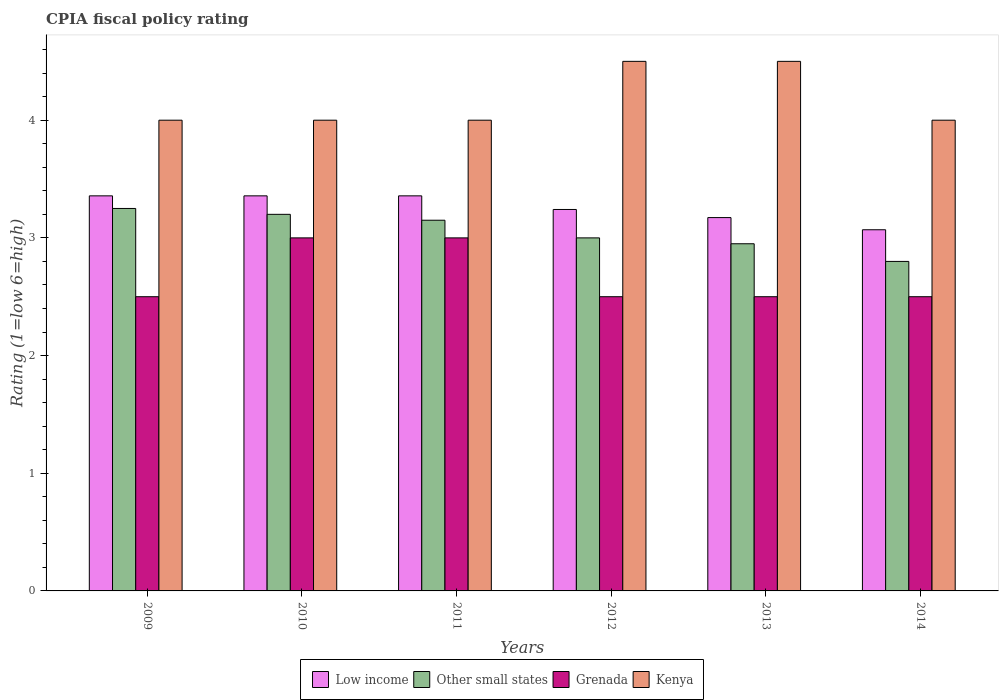How many different coloured bars are there?
Keep it short and to the point. 4. Are the number of bars per tick equal to the number of legend labels?
Give a very brief answer. Yes. How many bars are there on the 3rd tick from the left?
Give a very brief answer. 4. What is the label of the 5th group of bars from the left?
Keep it short and to the point. 2013. What is the CPIA rating in Kenya in 2013?
Provide a succinct answer. 4.5. Across all years, what is the maximum CPIA rating in Grenada?
Your answer should be very brief. 3. In which year was the CPIA rating in Low income minimum?
Your response must be concise. 2014. What is the total CPIA rating in Low income in the graph?
Give a very brief answer. 19.55. What is the difference between the CPIA rating in Other small states in 2010 and that in 2012?
Keep it short and to the point. 0.2. What is the difference between the CPIA rating in Grenada in 2010 and the CPIA rating in Kenya in 2009?
Make the answer very short. -1. What is the average CPIA rating in Kenya per year?
Your answer should be very brief. 4.17. In the year 2012, what is the difference between the CPIA rating in Kenya and CPIA rating in Low income?
Offer a terse response. 1.26. In how many years, is the CPIA rating in Grenada greater than 2.4?
Provide a short and direct response. 6. What is the ratio of the CPIA rating in Other small states in 2010 to that in 2013?
Offer a terse response. 1.08. Is the CPIA rating in Low income in 2012 less than that in 2014?
Make the answer very short. No. What is the difference between the highest and the lowest CPIA rating in Low income?
Ensure brevity in your answer.  0.29. What does the 2nd bar from the left in 2013 represents?
Ensure brevity in your answer.  Other small states. What does the 3rd bar from the right in 2012 represents?
Your answer should be compact. Other small states. How many bars are there?
Provide a short and direct response. 24. Are all the bars in the graph horizontal?
Offer a very short reply. No. Are the values on the major ticks of Y-axis written in scientific E-notation?
Provide a succinct answer. No. How many legend labels are there?
Give a very brief answer. 4. What is the title of the graph?
Your answer should be compact. CPIA fiscal policy rating. Does "Guatemala" appear as one of the legend labels in the graph?
Your answer should be very brief. No. What is the Rating (1=low 6=high) of Low income in 2009?
Offer a terse response. 3.36. What is the Rating (1=low 6=high) in Other small states in 2009?
Your answer should be compact. 3.25. What is the Rating (1=low 6=high) of Kenya in 2009?
Your answer should be very brief. 4. What is the Rating (1=low 6=high) in Low income in 2010?
Ensure brevity in your answer.  3.36. What is the Rating (1=low 6=high) in Grenada in 2010?
Your response must be concise. 3. What is the Rating (1=low 6=high) in Kenya in 2010?
Give a very brief answer. 4. What is the Rating (1=low 6=high) in Low income in 2011?
Your response must be concise. 3.36. What is the Rating (1=low 6=high) in Other small states in 2011?
Your response must be concise. 3.15. What is the Rating (1=low 6=high) of Grenada in 2011?
Ensure brevity in your answer.  3. What is the Rating (1=low 6=high) of Low income in 2012?
Your answer should be very brief. 3.24. What is the Rating (1=low 6=high) in Grenada in 2012?
Offer a very short reply. 2.5. What is the Rating (1=low 6=high) of Low income in 2013?
Make the answer very short. 3.17. What is the Rating (1=low 6=high) of Other small states in 2013?
Offer a terse response. 2.95. What is the Rating (1=low 6=high) in Kenya in 2013?
Provide a succinct answer. 4.5. What is the Rating (1=low 6=high) in Low income in 2014?
Provide a succinct answer. 3.07. What is the Rating (1=low 6=high) of Kenya in 2014?
Your answer should be compact. 4. Across all years, what is the maximum Rating (1=low 6=high) of Low income?
Your answer should be compact. 3.36. Across all years, what is the maximum Rating (1=low 6=high) in Other small states?
Ensure brevity in your answer.  3.25. Across all years, what is the maximum Rating (1=low 6=high) of Grenada?
Provide a succinct answer. 3. Across all years, what is the minimum Rating (1=low 6=high) in Low income?
Provide a succinct answer. 3.07. Across all years, what is the minimum Rating (1=low 6=high) of Grenada?
Offer a terse response. 2.5. What is the total Rating (1=low 6=high) in Low income in the graph?
Keep it short and to the point. 19.55. What is the total Rating (1=low 6=high) of Other small states in the graph?
Make the answer very short. 18.35. What is the total Rating (1=low 6=high) in Grenada in the graph?
Your answer should be very brief. 16. What is the difference between the Rating (1=low 6=high) of Grenada in 2009 and that in 2010?
Keep it short and to the point. -0.5. What is the difference between the Rating (1=low 6=high) in Grenada in 2009 and that in 2011?
Offer a terse response. -0.5. What is the difference between the Rating (1=low 6=high) in Kenya in 2009 and that in 2011?
Your answer should be compact. 0. What is the difference between the Rating (1=low 6=high) in Low income in 2009 and that in 2012?
Provide a short and direct response. 0.12. What is the difference between the Rating (1=low 6=high) in Grenada in 2009 and that in 2012?
Give a very brief answer. 0. What is the difference between the Rating (1=low 6=high) in Kenya in 2009 and that in 2012?
Offer a terse response. -0.5. What is the difference between the Rating (1=low 6=high) in Low income in 2009 and that in 2013?
Keep it short and to the point. 0.18. What is the difference between the Rating (1=low 6=high) of Low income in 2009 and that in 2014?
Ensure brevity in your answer.  0.29. What is the difference between the Rating (1=low 6=high) in Other small states in 2009 and that in 2014?
Offer a very short reply. 0.45. What is the difference between the Rating (1=low 6=high) in Kenya in 2009 and that in 2014?
Your answer should be compact. 0. What is the difference between the Rating (1=low 6=high) in Low income in 2010 and that in 2011?
Make the answer very short. 0. What is the difference between the Rating (1=low 6=high) of Grenada in 2010 and that in 2011?
Keep it short and to the point. 0. What is the difference between the Rating (1=low 6=high) of Low income in 2010 and that in 2012?
Your answer should be very brief. 0.12. What is the difference between the Rating (1=low 6=high) in Other small states in 2010 and that in 2012?
Your answer should be compact. 0.2. What is the difference between the Rating (1=low 6=high) of Grenada in 2010 and that in 2012?
Make the answer very short. 0.5. What is the difference between the Rating (1=low 6=high) of Kenya in 2010 and that in 2012?
Offer a very short reply. -0.5. What is the difference between the Rating (1=low 6=high) of Low income in 2010 and that in 2013?
Your answer should be very brief. 0.18. What is the difference between the Rating (1=low 6=high) in Grenada in 2010 and that in 2013?
Ensure brevity in your answer.  0.5. What is the difference between the Rating (1=low 6=high) in Low income in 2010 and that in 2014?
Offer a terse response. 0.29. What is the difference between the Rating (1=low 6=high) of Other small states in 2010 and that in 2014?
Make the answer very short. 0.4. What is the difference between the Rating (1=low 6=high) of Low income in 2011 and that in 2012?
Your answer should be very brief. 0.12. What is the difference between the Rating (1=low 6=high) of Kenya in 2011 and that in 2012?
Provide a succinct answer. -0.5. What is the difference between the Rating (1=low 6=high) of Low income in 2011 and that in 2013?
Your answer should be very brief. 0.18. What is the difference between the Rating (1=low 6=high) of Kenya in 2011 and that in 2013?
Keep it short and to the point. -0.5. What is the difference between the Rating (1=low 6=high) of Low income in 2011 and that in 2014?
Offer a terse response. 0.29. What is the difference between the Rating (1=low 6=high) of Other small states in 2011 and that in 2014?
Offer a terse response. 0.35. What is the difference between the Rating (1=low 6=high) of Grenada in 2011 and that in 2014?
Make the answer very short. 0.5. What is the difference between the Rating (1=low 6=high) of Kenya in 2011 and that in 2014?
Make the answer very short. 0. What is the difference between the Rating (1=low 6=high) of Low income in 2012 and that in 2013?
Keep it short and to the point. 0.07. What is the difference between the Rating (1=low 6=high) of Other small states in 2012 and that in 2013?
Make the answer very short. 0.05. What is the difference between the Rating (1=low 6=high) of Kenya in 2012 and that in 2013?
Give a very brief answer. 0. What is the difference between the Rating (1=low 6=high) of Low income in 2012 and that in 2014?
Offer a very short reply. 0.17. What is the difference between the Rating (1=low 6=high) of Other small states in 2012 and that in 2014?
Make the answer very short. 0.2. What is the difference between the Rating (1=low 6=high) in Grenada in 2012 and that in 2014?
Give a very brief answer. 0. What is the difference between the Rating (1=low 6=high) in Low income in 2013 and that in 2014?
Provide a succinct answer. 0.1. What is the difference between the Rating (1=low 6=high) of Grenada in 2013 and that in 2014?
Offer a very short reply. 0. What is the difference between the Rating (1=low 6=high) of Low income in 2009 and the Rating (1=low 6=high) of Other small states in 2010?
Make the answer very short. 0.16. What is the difference between the Rating (1=low 6=high) in Low income in 2009 and the Rating (1=low 6=high) in Grenada in 2010?
Keep it short and to the point. 0.36. What is the difference between the Rating (1=low 6=high) of Low income in 2009 and the Rating (1=low 6=high) of Kenya in 2010?
Keep it short and to the point. -0.64. What is the difference between the Rating (1=low 6=high) of Other small states in 2009 and the Rating (1=low 6=high) of Grenada in 2010?
Your answer should be very brief. 0.25. What is the difference between the Rating (1=low 6=high) in Other small states in 2009 and the Rating (1=low 6=high) in Kenya in 2010?
Provide a succinct answer. -0.75. What is the difference between the Rating (1=low 6=high) in Low income in 2009 and the Rating (1=low 6=high) in Other small states in 2011?
Give a very brief answer. 0.21. What is the difference between the Rating (1=low 6=high) of Low income in 2009 and the Rating (1=low 6=high) of Grenada in 2011?
Your answer should be compact. 0.36. What is the difference between the Rating (1=low 6=high) in Low income in 2009 and the Rating (1=low 6=high) in Kenya in 2011?
Your answer should be compact. -0.64. What is the difference between the Rating (1=low 6=high) of Other small states in 2009 and the Rating (1=low 6=high) of Grenada in 2011?
Offer a very short reply. 0.25. What is the difference between the Rating (1=low 6=high) in Other small states in 2009 and the Rating (1=low 6=high) in Kenya in 2011?
Your answer should be very brief. -0.75. What is the difference between the Rating (1=low 6=high) of Low income in 2009 and the Rating (1=low 6=high) of Other small states in 2012?
Your response must be concise. 0.36. What is the difference between the Rating (1=low 6=high) of Low income in 2009 and the Rating (1=low 6=high) of Kenya in 2012?
Offer a terse response. -1.14. What is the difference between the Rating (1=low 6=high) of Other small states in 2009 and the Rating (1=low 6=high) of Kenya in 2012?
Provide a short and direct response. -1.25. What is the difference between the Rating (1=low 6=high) of Low income in 2009 and the Rating (1=low 6=high) of Other small states in 2013?
Provide a short and direct response. 0.41. What is the difference between the Rating (1=low 6=high) of Low income in 2009 and the Rating (1=low 6=high) of Grenada in 2013?
Offer a terse response. 0.86. What is the difference between the Rating (1=low 6=high) of Low income in 2009 and the Rating (1=low 6=high) of Kenya in 2013?
Ensure brevity in your answer.  -1.14. What is the difference between the Rating (1=low 6=high) in Other small states in 2009 and the Rating (1=low 6=high) in Grenada in 2013?
Make the answer very short. 0.75. What is the difference between the Rating (1=low 6=high) in Other small states in 2009 and the Rating (1=low 6=high) in Kenya in 2013?
Offer a terse response. -1.25. What is the difference between the Rating (1=low 6=high) of Grenada in 2009 and the Rating (1=low 6=high) of Kenya in 2013?
Give a very brief answer. -2. What is the difference between the Rating (1=low 6=high) of Low income in 2009 and the Rating (1=low 6=high) of Other small states in 2014?
Offer a very short reply. 0.56. What is the difference between the Rating (1=low 6=high) in Low income in 2009 and the Rating (1=low 6=high) in Grenada in 2014?
Make the answer very short. 0.86. What is the difference between the Rating (1=low 6=high) in Low income in 2009 and the Rating (1=low 6=high) in Kenya in 2014?
Provide a short and direct response. -0.64. What is the difference between the Rating (1=low 6=high) of Other small states in 2009 and the Rating (1=low 6=high) of Kenya in 2014?
Give a very brief answer. -0.75. What is the difference between the Rating (1=low 6=high) of Grenada in 2009 and the Rating (1=low 6=high) of Kenya in 2014?
Offer a very short reply. -1.5. What is the difference between the Rating (1=low 6=high) of Low income in 2010 and the Rating (1=low 6=high) of Other small states in 2011?
Provide a succinct answer. 0.21. What is the difference between the Rating (1=low 6=high) of Low income in 2010 and the Rating (1=low 6=high) of Grenada in 2011?
Keep it short and to the point. 0.36. What is the difference between the Rating (1=low 6=high) of Low income in 2010 and the Rating (1=low 6=high) of Kenya in 2011?
Ensure brevity in your answer.  -0.64. What is the difference between the Rating (1=low 6=high) in Low income in 2010 and the Rating (1=low 6=high) in Other small states in 2012?
Keep it short and to the point. 0.36. What is the difference between the Rating (1=low 6=high) in Low income in 2010 and the Rating (1=low 6=high) in Grenada in 2012?
Offer a terse response. 0.86. What is the difference between the Rating (1=low 6=high) of Low income in 2010 and the Rating (1=low 6=high) of Kenya in 2012?
Provide a succinct answer. -1.14. What is the difference between the Rating (1=low 6=high) in Other small states in 2010 and the Rating (1=low 6=high) in Kenya in 2012?
Offer a terse response. -1.3. What is the difference between the Rating (1=low 6=high) in Low income in 2010 and the Rating (1=low 6=high) in Other small states in 2013?
Offer a very short reply. 0.41. What is the difference between the Rating (1=low 6=high) of Low income in 2010 and the Rating (1=low 6=high) of Grenada in 2013?
Provide a short and direct response. 0.86. What is the difference between the Rating (1=low 6=high) in Low income in 2010 and the Rating (1=low 6=high) in Kenya in 2013?
Make the answer very short. -1.14. What is the difference between the Rating (1=low 6=high) in Other small states in 2010 and the Rating (1=low 6=high) in Grenada in 2013?
Keep it short and to the point. 0.7. What is the difference between the Rating (1=low 6=high) of Other small states in 2010 and the Rating (1=low 6=high) of Kenya in 2013?
Provide a short and direct response. -1.3. What is the difference between the Rating (1=low 6=high) of Grenada in 2010 and the Rating (1=low 6=high) of Kenya in 2013?
Your answer should be compact. -1.5. What is the difference between the Rating (1=low 6=high) in Low income in 2010 and the Rating (1=low 6=high) in Other small states in 2014?
Keep it short and to the point. 0.56. What is the difference between the Rating (1=low 6=high) in Low income in 2010 and the Rating (1=low 6=high) in Grenada in 2014?
Provide a succinct answer. 0.86. What is the difference between the Rating (1=low 6=high) of Low income in 2010 and the Rating (1=low 6=high) of Kenya in 2014?
Your answer should be compact. -0.64. What is the difference between the Rating (1=low 6=high) in Other small states in 2010 and the Rating (1=low 6=high) in Kenya in 2014?
Provide a succinct answer. -0.8. What is the difference between the Rating (1=low 6=high) of Low income in 2011 and the Rating (1=low 6=high) of Other small states in 2012?
Offer a very short reply. 0.36. What is the difference between the Rating (1=low 6=high) in Low income in 2011 and the Rating (1=low 6=high) in Grenada in 2012?
Ensure brevity in your answer.  0.86. What is the difference between the Rating (1=low 6=high) in Low income in 2011 and the Rating (1=low 6=high) in Kenya in 2012?
Give a very brief answer. -1.14. What is the difference between the Rating (1=low 6=high) in Other small states in 2011 and the Rating (1=low 6=high) in Grenada in 2012?
Your response must be concise. 0.65. What is the difference between the Rating (1=low 6=high) in Other small states in 2011 and the Rating (1=low 6=high) in Kenya in 2012?
Offer a very short reply. -1.35. What is the difference between the Rating (1=low 6=high) of Grenada in 2011 and the Rating (1=low 6=high) of Kenya in 2012?
Provide a short and direct response. -1.5. What is the difference between the Rating (1=low 6=high) in Low income in 2011 and the Rating (1=low 6=high) in Other small states in 2013?
Your answer should be very brief. 0.41. What is the difference between the Rating (1=low 6=high) in Low income in 2011 and the Rating (1=low 6=high) in Kenya in 2013?
Your answer should be compact. -1.14. What is the difference between the Rating (1=low 6=high) of Other small states in 2011 and the Rating (1=low 6=high) of Grenada in 2013?
Provide a short and direct response. 0.65. What is the difference between the Rating (1=low 6=high) of Other small states in 2011 and the Rating (1=low 6=high) of Kenya in 2013?
Keep it short and to the point. -1.35. What is the difference between the Rating (1=low 6=high) in Low income in 2011 and the Rating (1=low 6=high) in Other small states in 2014?
Provide a short and direct response. 0.56. What is the difference between the Rating (1=low 6=high) in Low income in 2011 and the Rating (1=low 6=high) in Kenya in 2014?
Give a very brief answer. -0.64. What is the difference between the Rating (1=low 6=high) of Other small states in 2011 and the Rating (1=low 6=high) of Grenada in 2014?
Your response must be concise. 0.65. What is the difference between the Rating (1=low 6=high) in Other small states in 2011 and the Rating (1=low 6=high) in Kenya in 2014?
Make the answer very short. -0.85. What is the difference between the Rating (1=low 6=high) in Grenada in 2011 and the Rating (1=low 6=high) in Kenya in 2014?
Ensure brevity in your answer.  -1. What is the difference between the Rating (1=low 6=high) of Low income in 2012 and the Rating (1=low 6=high) of Other small states in 2013?
Make the answer very short. 0.29. What is the difference between the Rating (1=low 6=high) in Low income in 2012 and the Rating (1=low 6=high) in Grenada in 2013?
Offer a very short reply. 0.74. What is the difference between the Rating (1=low 6=high) of Low income in 2012 and the Rating (1=low 6=high) of Kenya in 2013?
Ensure brevity in your answer.  -1.26. What is the difference between the Rating (1=low 6=high) of Other small states in 2012 and the Rating (1=low 6=high) of Grenada in 2013?
Make the answer very short. 0.5. What is the difference between the Rating (1=low 6=high) of Low income in 2012 and the Rating (1=low 6=high) of Other small states in 2014?
Ensure brevity in your answer.  0.44. What is the difference between the Rating (1=low 6=high) of Low income in 2012 and the Rating (1=low 6=high) of Grenada in 2014?
Ensure brevity in your answer.  0.74. What is the difference between the Rating (1=low 6=high) of Low income in 2012 and the Rating (1=low 6=high) of Kenya in 2014?
Keep it short and to the point. -0.76. What is the difference between the Rating (1=low 6=high) of Other small states in 2012 and the Rating (1=low 6=high) of Kenya in 2014?
Give a very brief answer. -1. What is the difference between the Rating (1=low 6=high) in Grenada in 2012 and the Rating (1=low 6=high) in Kenya in 2014?
Keep it short and to the point. -1.5. What is the difference between the Rating (1=low 6=high) of Low income in 2013 and the Rating (1=low 6=high) of Other small states in 2014?
Ensure brevity in your answer.  0.37. What is the difference between the Rating (1=low 6=high) of Low income in 2013 and the Rating (1=low 6=high) of Grenada in 2014?
Give a very brief answer. 0.67. What is the difference between the Rating (1=low 6=high) in Low income in 2013 and the Rating (1=low 6=high) in Kenya in 2014?
Your response must be concise. -0.83. What is the difference between the Rating (1=low 6=high) in Other small states in 2013 and the Rating (1=low 6=high) in Grenada in 2014?
Provide a short and direct response. 0.45. What is the difference between the Rating (1=low 6=high) in Other small states in 2013 and the Rating (1=low 6=high) in Kenya in 2014?
Your answer should be very brief. -1.05. What is the average Rating (1=low 6=high) of Low income per year?
Your answer should be compact. 3.26. What is the average Rating (1=low 6=high) of Other small states per year?
Give a very brief answer. 3.06. What is the average Rating (1=low 6=high) of Grenada per year?
Provide a succinct answer. 2.67. What is the average Rating (1=low 6=high) of Kenya per year?
Offer a very short reply. 4.17. In the year 2009, what is the difference between the Rating (1=low 6=high) of Low income and Rating (1=low 6=high) of Other small states?
Ensure brevity in your answer.  0.11. In the year 2009, what is the difference between the Rating (1=low 6=high) in Low income and Rating (1=low 6=high) in Grenada?
Make the answer very short. 0.86. In the year 2009, what is the difference between the Rating (1=low 6=high) of Low income and Rating (1=low 6=high) of Kenya?
Provide a short and direct response. -0.64. In the year 2009, what is the difference between the Rating (1=low 6=high) of Other small states and Rating (1=low 6=high) of Kenya?
Offer a terse response. -0.75. In the year 2009, what is the difference between the Rating (1=low 6=high) in Grenada and Rating (1=low 6=high) in Kenya?
Keep it short and to the point. -1.5. In the year 2010, what is the difference between the Rating (1=low 6=high) of Low income and Rating (1=low 6=high) of Other small states?
Ensure brevity in your answer.  0.16. In the year 2010, what is the difference between the Rating (1=low 6=high) in Low income and Rating (1=low 6=high) in Grenada?
Make the answer very short. 0.36. In the year 2010, what is the difference between the Rating (1=low 6=high) in Low income and Rating (1=low 6=high) in Kenya?
Provide a succinct answer. -0.64. In the year 2010, what is the difference between the Rating (1=low 6=high) of Other small states and Rating (1=low 6=high) of Grenada?
Your response must be concise. 0.2. In the year 2010, what is the difference between the Rating (1=low 6=high) of Other small states and Rating (1=low 6=high) of Kenya?
Your response must be concise. -0.8. In the year 2011, what is the difference between the Rating (1=low 6=high) in Low income and Rating (1=low 6=high) in Other small states?
Ensure brevity in your answer.  0.21. In the year 2011, what is the difference between the Rating (1=low 6=high) of Low income and Rating (1=low 6=high) of Grenada?
Your response must be concise. 0.36. In the year 2011, what is the difference between the Rating (1=low 6=high) in Low income and Rating (1=low 6=high) in Kenya?
Offer a very short reply. -0.64. In the year 2011, what is the difference between the Rating (1=low 6=high) in Other small states and Rating (1=low 6=high) in Kenya?
Offer a very short reply. -0.85. In the year 2012, what is the difference between the Rating (1=low 6=high) of Low income and Rating (1=low 6=high) of Other small states?
Offer a very short reply. 0.24. In the year 2012, what is the difference between the Rating (1=low 6=high) in Low income and Rating (1=low 6=high) in Grenada?
Provide a short and direct response. 0.74. In the year 2012, what is the difference between the Rating (1=low 6=high) of Low income and Rating (1=low 6=high) of Kenya?
Give a very brief answer. -1.26. In the year 2012, what is the difference between the Rating (1=low 6=high) in Other small states and Rating (1=low 6=high) in Kenya?
Give a very brief answer. -1.5. In the year 2013, what is the difference between the Rating (1=low 6=high) in Low income and Rating (1=low 6=high) in Other small states?
Give a very brief answer. 0.22. In the year 2013, what is the difference between the Rating (1=low 6=high) of Low income and Rating (1=low 6=high) of Grenada?
Offer a very short reply. 0.67. In the year 2013, what is the difference between the Rating (1=low 6=high) in Low income and Rating (1=low 6=high) in Kenya?
Your response must be concise. -1.33. In the year 2013, what is the difference between the Rating (1=low 6=high) of Other small states and Rating (1=low 6=high) of Grenada?
Offer a terse response. 0.45. In the year 2013, what is the difference between the Rating (1=low 6=high) of Other small states and Rating (1=low 6=high) of Kenya?
Ensure brevity in your answer.  -1.55. In the year 2014, what is the difference between the Rating (1=low 6=high) of Low income and Rating (1=low 6=high) of Other small states?
Your answer should be compact. 0.27. In the year 2014, what is the difference between the Rating (1=low 6=high) of Low income and Rating (1=low 6=high) of Grenada?
Provide a succinct answer. 0.57. In the year 2014, what is the difference between the Rating (1=low 6=high) of Low income and Rating (1=low 6=high) of Kenya?
Offer a very short reply. -0.93. What is the ratio of the Rating (1=low 6=high) of Low income in 2009 to that in 2010?
Provide a succinct answer. 1. What is the ratio of the Rating (1=low 6=high) of Other small states in 2009 to that in 2010?
Make the answer very short. 1.02. What is the ratio of the Rating (1=low 6=high) of Kenya in 2009 to that in 2010?
Offer a terse response. 1. What is the ratio of the Rating (1=low 6=high) in Low income in 2009 to that in 2011?
Provide a succinct answer. 1. What is the ratio of the Rating (1=low 6=high) of Other small states in 2009 to that in 2011?
Give a very brief answer. 1.03. What is the ratio of the Rating (1=low 6=high) of Grenada in 2009 to that in 2011?
Provide a succinct answer. 0.83. What is the ratio of the Rating (1=low 6=high) of Low income in 2009 to that in 2012?
Your answer should be compact. 1.04. What is the ratio of the Rating (1=low 6=high) of Low income in 2009 to that in 2013?
Give a very brief answer. 1.06. What is the ratio of the Rating (1=low 6=high) in Other small states in 2009 to that in 2013?
Make the answer very short. 1.1. What is the ratio of the Rating (1=low 6=high) in Grenada in 2009 to that in 2013?
Make the answer very short. 1. What is the ratio of the Rating (1=low 6=high) of Kenya in 2009 to that in 2013?
Provide a short and direct response. 0.89. What is the ratio of the Rating (1=low 6=high) in Low income in 2009 to that in 2014?
Ensure brevity in your answer.  1.09. What is the ratio of the Rating (1=low 6=high) in Other small states in 2009 to that in 2014?
Your answer should be compact. 1.16. What is the ratio of the Rating (1=low 6=high) of Other small states in 2010 to that in 2011?
Provide a succinct answer. 1.02. What is the ratio of the Rating (1=low 6=high) in Grenada in 2010 to that in 2011?
Make the answer very short. 1. What is the ratio of the Rating (1=low 6=high) in Low income in 2010 to that in 2012?
Your response must be concise. 1.04. What is the ratio of the Rating (1=low 6=high) of Other small states in 2010 to that in 2012?
Your answer should be very brief. 1.07. What is the ratio of the Rating (1=low 6=high) in Kenya in 2010 to that in 2012?
Your answer should be compact. 0.89. What is the ratio of the Rating (1=low 6=high) in Low income in 2010 to that in 2013?
Your answer should be very brief. 1.06. What is the ratio of the Rating (1=low 6=high) of Other small states in 2010 to that in 2013?
Your response must be concise. 1.08. What is the ratio of the Rating (1=low 6=high) of Low income in 2010 to that in 2014?
Offer a very short reply. 1.09. What is the ratio of the Rating (1=low 6=high) of Low income in 2011 to that in 2012?
Your answer should be very brief. 1.04. What is the ratio of the Rating (1=low 6=high) in Grenada in 2011 to that in 2012?
Ensure brevity in your answer.  1.2. What is the ratio of the Rating (1=low 6=high) of Kenya in 2011 to that in 2012?
Your answer should be compact. 0.89. What is the ratio of the Rating (1=low 6=high) of Low income in 2011 to that in 2013?
Provide a succinct answer. 1.06. What is the ratio of the Rating (1=low 6=high) in Other small states in 2011 to that in 2013?
Provide a succinct answer. 1.07. What is the ratio of the Rating (1=low 6=high) of Kenya in 2011 to that in 2013?
Ensure brevity in your answer.  0.89. What is the ratio of the Rating (1=low 6=high) in Low income in 2011 to that in 2014?
Your response must be concise. 1.09. What is the ratio of the Rating (1=low 6=high) of Other small states in 2011 to that in 2014?
Keep it short and to the point. 1.12. What is the ratio of the Rating (1=low 6=high) in Low income in 2012 to that in 2013?
Give a very brief answer. 1.02. What is the ratio of the Rating (1=low 6=high) in Other small states in 2012 to that in 2013?
Provide a succinct answer. 1.02. What is the ratio of the Rating (1=low 6=high) in Grenada in 2012 to that in 2013?
Provide a short and direct response. 1. What is the ratio of the Rating (1=low 6=high) in Low income in 2012 to that in 2014?
Your answer should be very brief. 1.06. What is the ratio of the Rating (1=low 6=high) of Other small states in 2012 to that in 2014?
Ensure brevity in your answer.  1.07. What is the ratio of the Rating (1=low 6=high) of Grenada in 2012 to that in 2014?
Your response must be concise. 1. What is the ratio of the Rating (1=low 6=high) of Kenya in 2012 to that in 2014?
Offer a terse response. 1.12. What is the ratio of the Rating (1=low 6=high) of Low income in 2013 to that in 2014?
Give a very brief answer. 1.03. What is the ratio of the Rating (1=low 6=high) in Other small states in 2013 to that in 2014?
Make the answer very short. 1.05. What is the difference between the highest and the second highest Rating (1=low 6=high) of Low income?
Your response must be concise. 0. What is the difference between the highest and the second highest Rating (1=low 6=high) in Grenada?
Offer a very short reply. 0. What is the difference between the highest and the second highest Rating (1=low 6=high) of Kenya?
Offer a very short reply. 0. What is the difference between the highest and the lowest Rating (1=low 6=high) in Low income?
Your answer should be compact. 0.29. What is the difference between the highest and the lowest Rating (1=low 6=high) of Other small states?
Give a very brief answer. 0.45. 